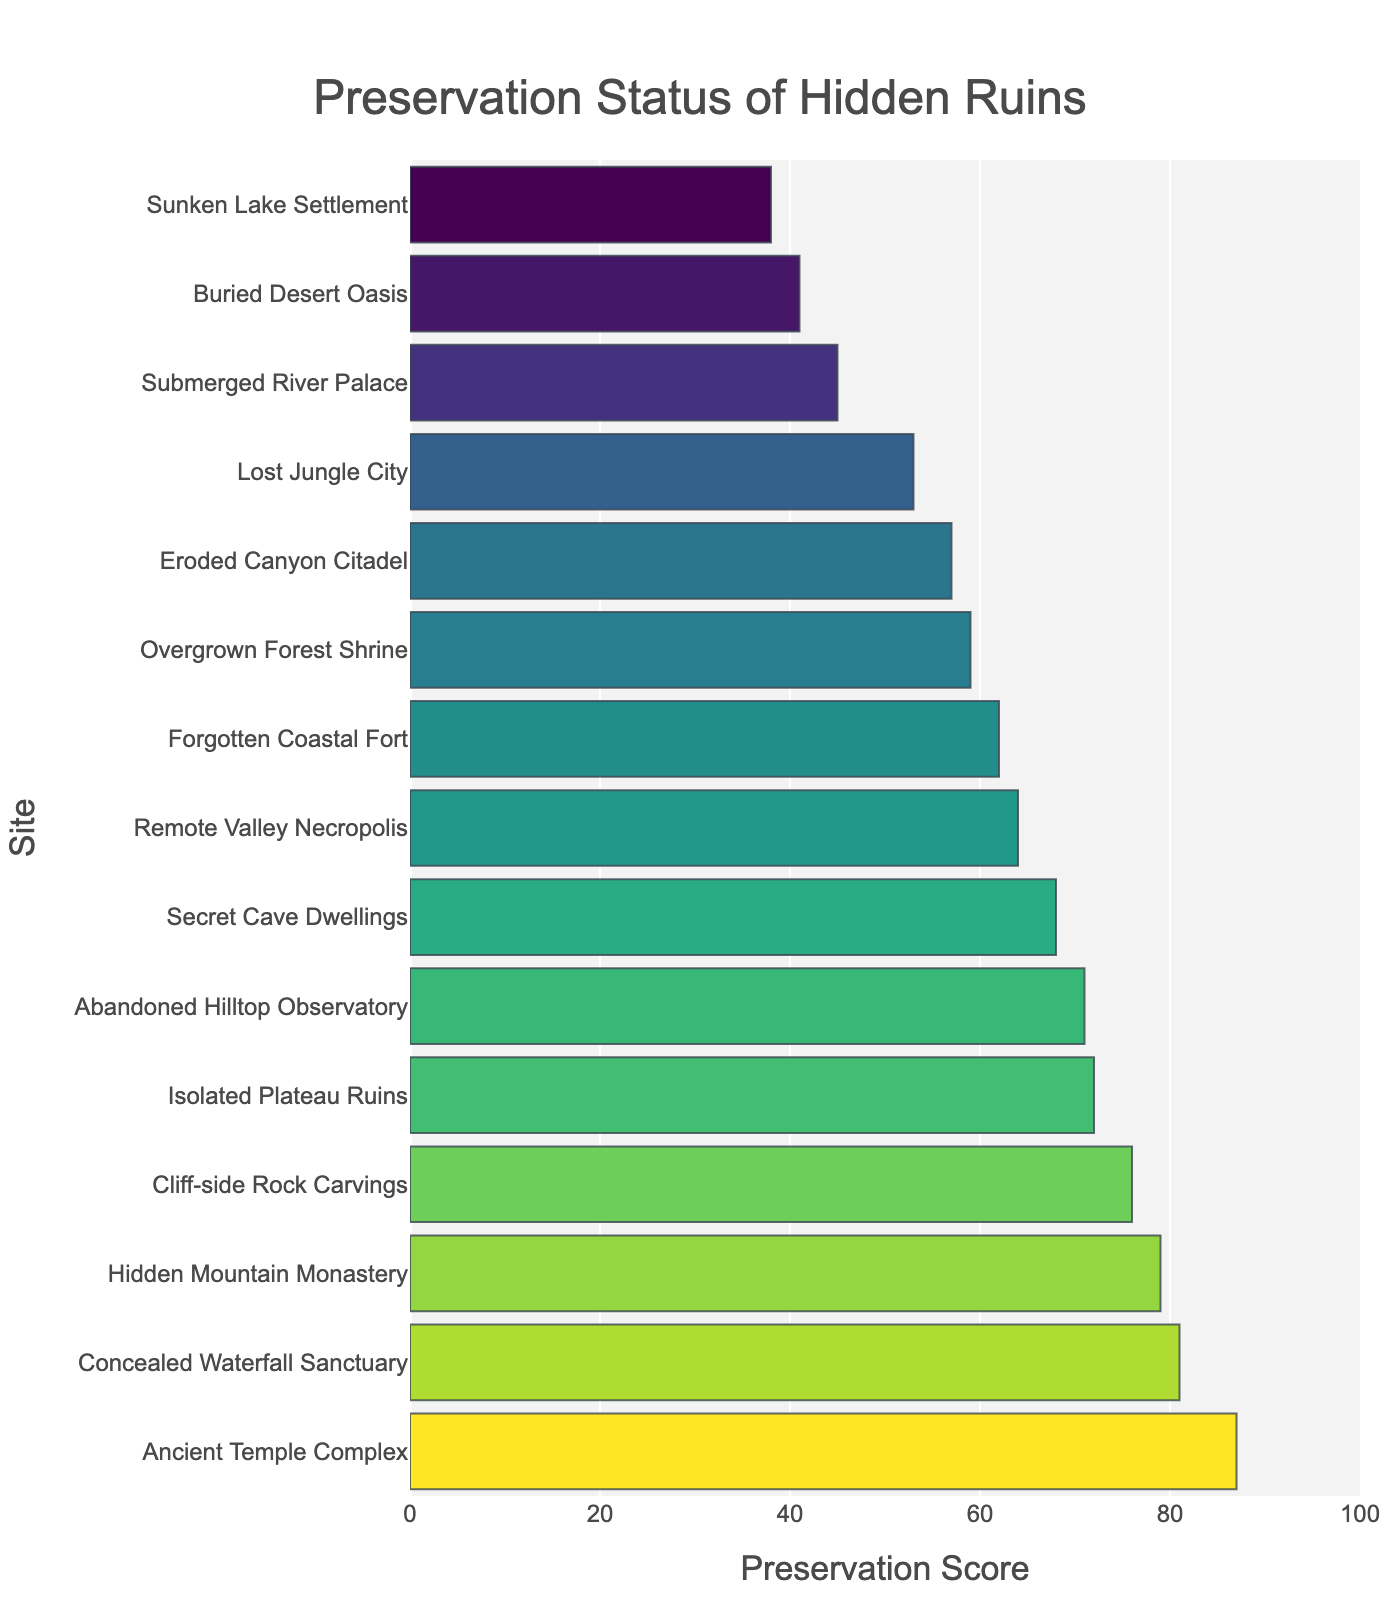Which site has the highest preservation score? Locate the bar that reaches the farthest to the right. The Ancient Temple Complex has the longest bar, indicating the highest preservation score.
Answer: Ancient Temple Complex Which site has the lowest preservation score? Find the bar that is shortest or extends the least to the right. The Sunken Lake Settlement has the shortest bar, indicating the lowest preservation score.
Answer: Sunken Lake Settlement Compare the preservation scores of the Abandoned Hilltop Observatory and the Secret Cave Dwellings. Which one is higher? Compare the lengths of the bars for these two sites. The bar for the Abandoned Hilltop Observatory is longer than that for the Secret Cave Dwellings.
Answer: Abandoned Hilltop Observatory What is the difference in preservation score between the Hidden Mountain Monastery and the Cliff-side Rock Carvings? Subtract the preservation score of the Cliff-side Rock Carvings (76) from that of the Hidden Mountain Monastery (79).
Answer: 3 Which sites have a preservation score greater than 70? Identify the bars that extend beyond the value of 70 on the x-axis. These sites are: Ancient Temple Complex, Hidden Mountain Monastery, Abandoned Hilltop Observatory, Isolated Plateau Ruins, Concealed Waterfall Sanctuary, and Cliff-side Rock Carvings.
Answer: Ancient Temple Complex, Hidden Mountain Monastery, Abandoned Hilltop Observatory, Isolated Plateau Ruins, Concealed Waterfall Sanctuary, Cliff-side Rock Carvings What is the average preservation score of the Forgotten Coastal Fort, Lost Jungle City, and Overgrown Forest Shrine? Add their preservation scores (62 + 53 + 59) and divide by the number of sites (3).
Answer: 58 By how much does the preservation score of the Submerged River Palace differ from the Buried Desert Oasis? Subtract the preservation score of the Buried Desert Oasis (41) from that of the Submerged River Palace (45).
Answer: 4 Which site among the Overgrown Forest Shrine, Remote Valley Necropolis, and Eroded Canyon Citadel has the highest preservation score, and what is it? Compare the lengths of the bars for these sites. The Remote Valley Necropolis has the longest bar among them.
Answer: Remote Valley Necropolis, 64 Are there any sites with a preservation score exactly equal to 81? Identify if any bar extends to the value of 81 on the x-axis. The Concealed Waterfall Sanctuary reaches this value.
Answer: Concealed Waterfall Sanctuary 